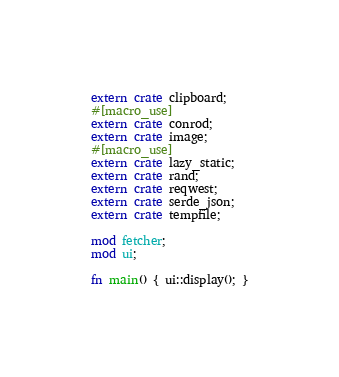Convert code to text. <code><loc_0><loc_0><loc_500><loc_500><_Rust_>extern crate clipboard;
#[macro_use]
extern crate conrod;
extern crate image;
#[macro_use]
extern crate lazy_static;
extern crate rand;
extern crate reqwest;
extern crate serde_json;
extern crate tempfile;

mod fetcher;
mod ui;

fn main() { ui::display(); }
</code> 